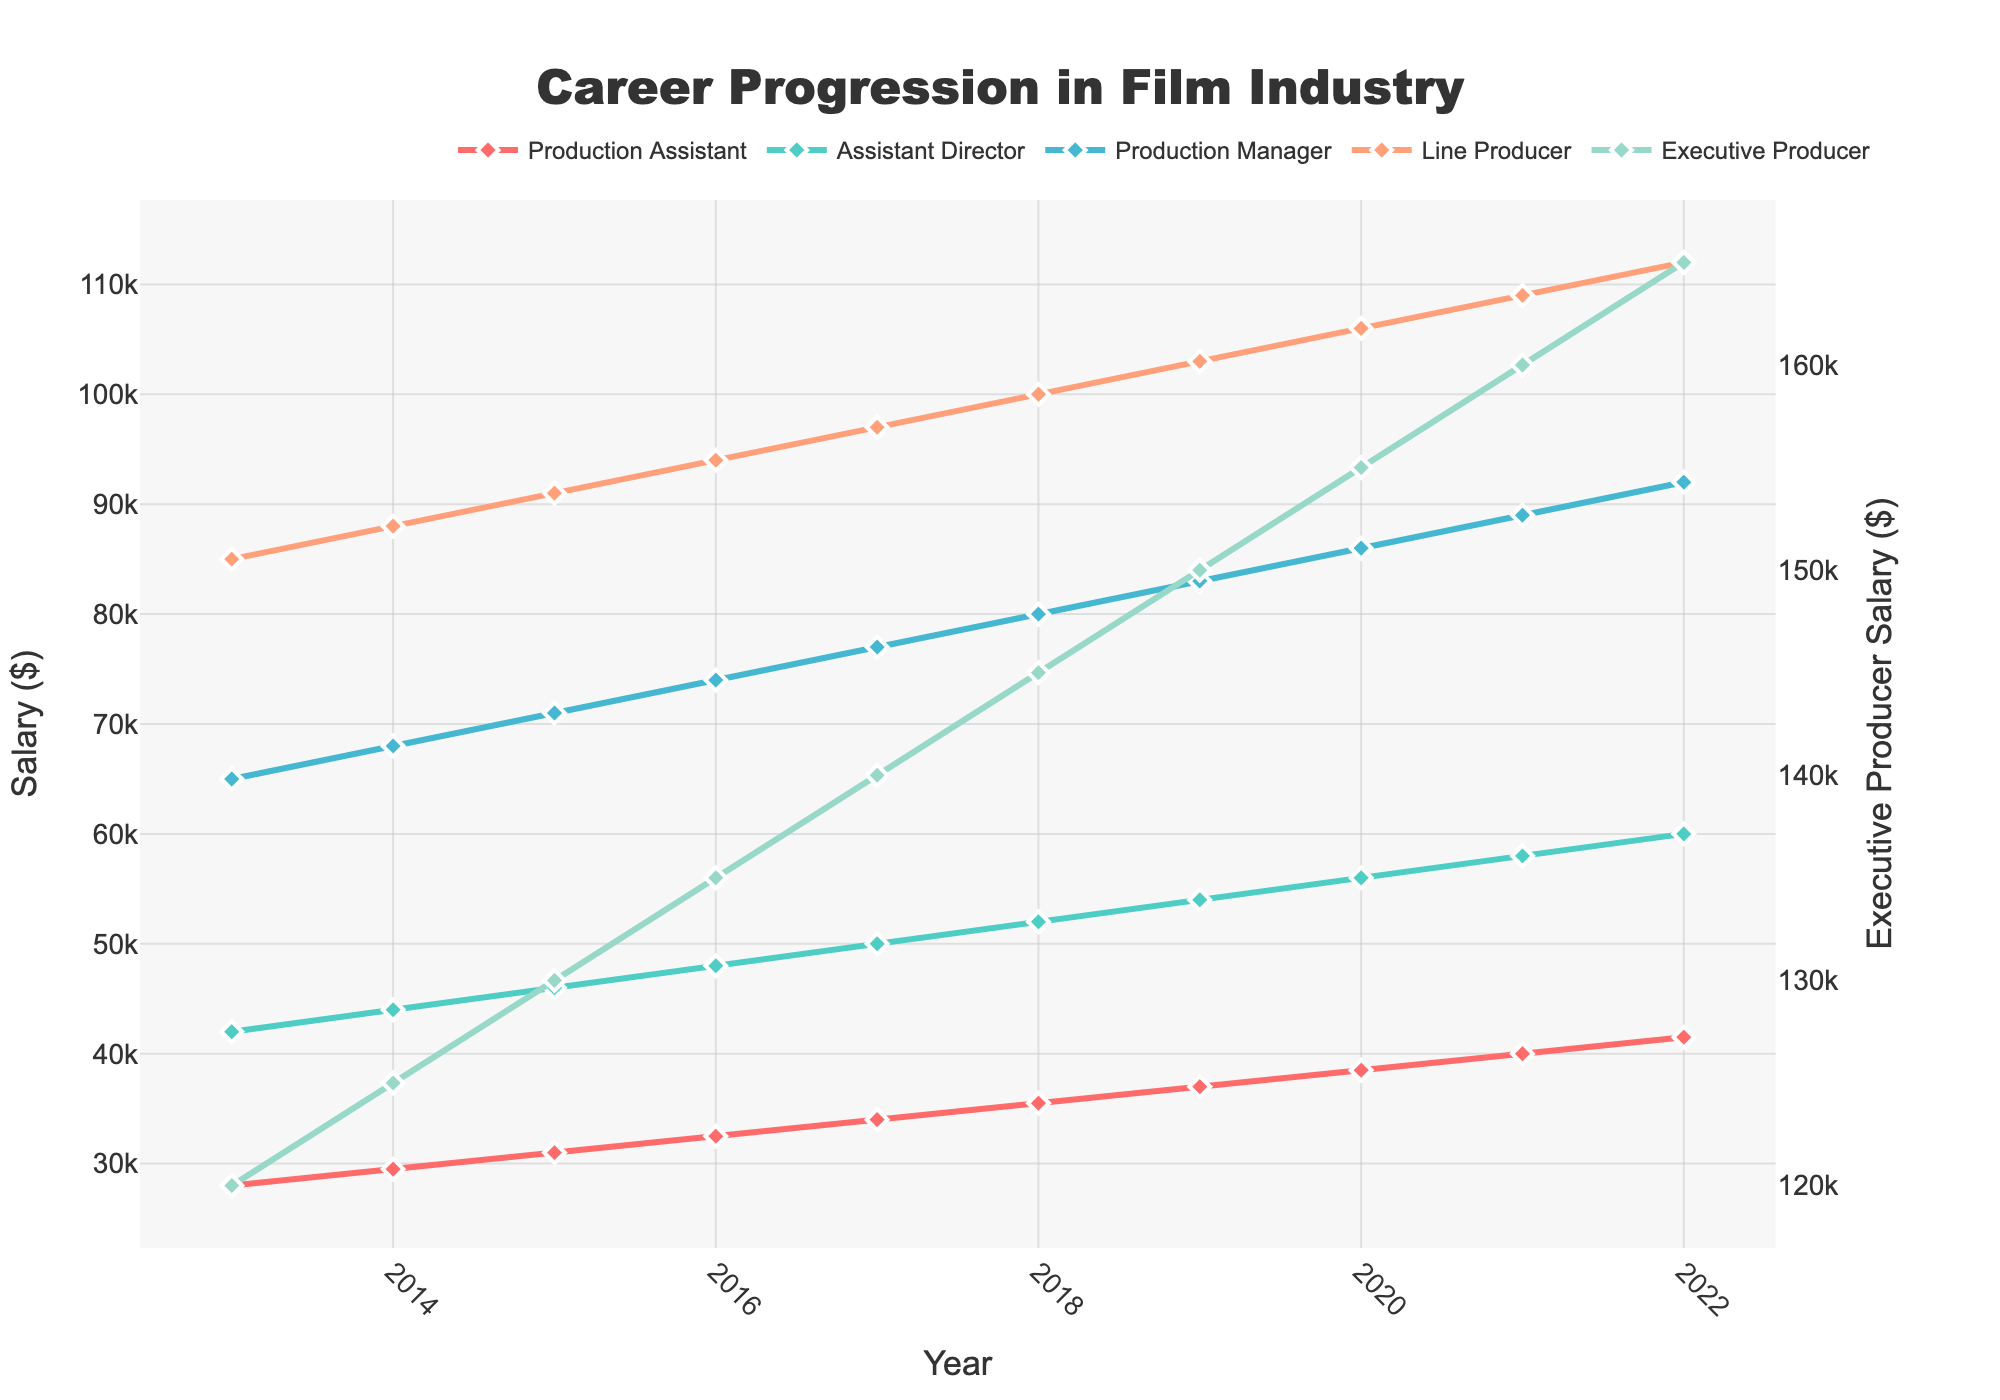What is the average salary of a Production Manager in 2018 and 2019? First, locate the salaries for the Production Manager role in 2018 and 2019 from the chart, which are $80,000 and $83,000, respectively. Add them up: $80,000 + $83,000 = $163,000. Then divide by 2 to find the average: $163,000 / 2 = $81,500.
Answer: $81,500 Which year shows the maximum salary increase for the Executive Producer role? To determine this, observe the difference in salaries year-over-year for the Executive Producer role. From 2013 to 2014, the increase is $5,000 ($125,000 - $120,000). Check each year similarly. From 2021 to 2022, the increase is $5,000, equal to 2019 to 2022. The salary consistently increases by the same difference each year, but the first major increase was noted in 2013 to 2014.
Answer: 2013-2014 Which role had the smallest salary range between 2013 and 2022? To find the salary range, subtract the minimum salary from the maximum salary for each role using the chart data. Production Assistant: $41,500 - $28,000 = $13,500. Assistant Director: $60,000 - $42,000 = $18,000. Production Manager: $92,000 - $65,000 = $27,000. Line Producer: $112,000 - $85,000 = $27,000. Executive Producer: $165,000 - $120,000 = $45,000. Therefore, the Production Assistant has the smallest range.
Answer: Production Assistant How much did the salary for the Assistant Director increase from 2015 to 2017? Identify the salaries for the Assistant Director role in 2015 and 2017, which are $46,000 and $50,000, respectively. Calculate the difference: $50,000 - $46,000 = $4,000.
Answer: $4,000 Which role consistently showed an increase in salary each year, and by how much approximately per year for the Line Producer? From the chart, all roles consistently show an annual salary increase. To find the approximate increase per year for the Line Producer, take the salary difference from 2013 to 2022: $112,000 - $85,000 = $27,000 and divide by the number of years (2022-2013 = 9). So, $27,000 / 9 = $3,000.
Answer: Line Producer; $3,000 per year In which year did the Production Assistant role surpass a salary of $35,000? Locate the salary trend line for the Production Assistant. In 2018, the salary increased to $35,500 which first surpasses $35,000.
Answer: 2018 